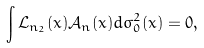<formula> <loc_0><loc_0><loc_500><loc_500>\int { \mathcal { L } } _ { { n } _ { 2 } } ( x ) { \mathcal { A } } _ { n } ( x ) d \sigma _ { 0 } ^ { 2 } ( x ) = 0 ,</formula> 